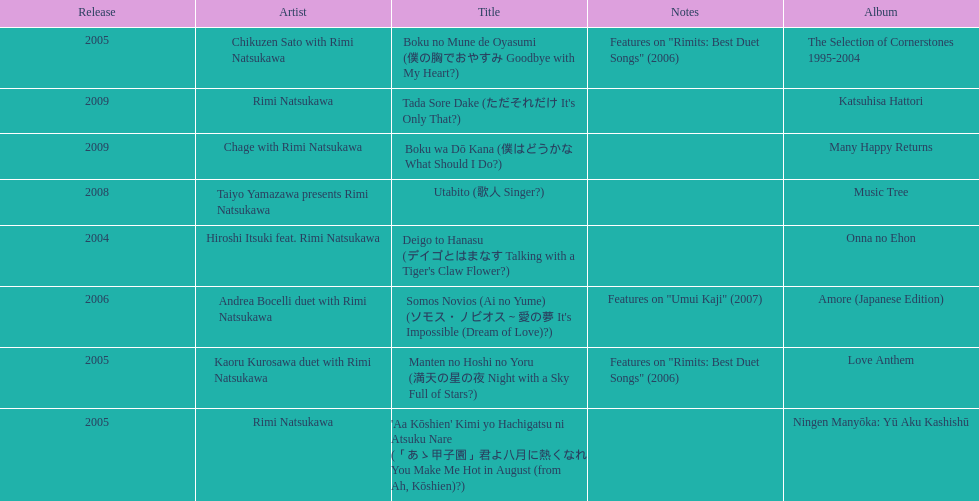Which is the latest title to be released? 2009. 